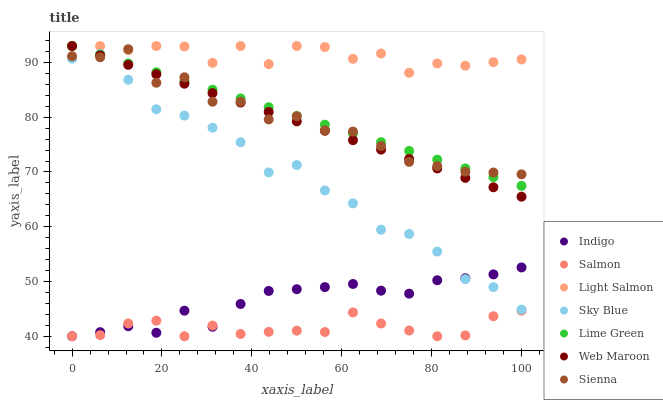Does Salmon have the minimum area under the curve?
Answer yes or no. Yes. Does Light Salmon have the maximum area under the curve?
Answer yes or no. Yes. Does Indigo have the minimum area under the curve?
Answer yes or no. No. Does Indigo have the maximum area under the curve?
Answer yes or no. No. Is Web Maroon the smoothest?
Answer yes or no. Yes. Is Sky Blue the roughest?
Answer yes or no. Yes. Is Indigo the smoothest?
Answer yes or no. No. Is Indigo the roughest?
Answer yes or no. No. Does Indigo have the lowest value?
Answer yes or no. Yes. Does Web Maroon have the lowest value?
Answer yes or no. No. Does Lime Green have the highest value?
Answer yes or no. Yes. Does Indigo have the highest value?
Answer yes or no. No. Is Salmon less than Web Maroon?
Answer yes or no. Yes. Is Sienna greater than Indigo?
Answer yes or no. Yes. Does Indigo intersect Sky Blue?
Answer yes or no. Yes. Is Indigo less than Sky Blue?
Answer yes or no. No. Is Indigo greater than Sky Blue?
Answer yes or no. No. Does Salmon intersect Web Maroon?
Answer yes or no. No. 